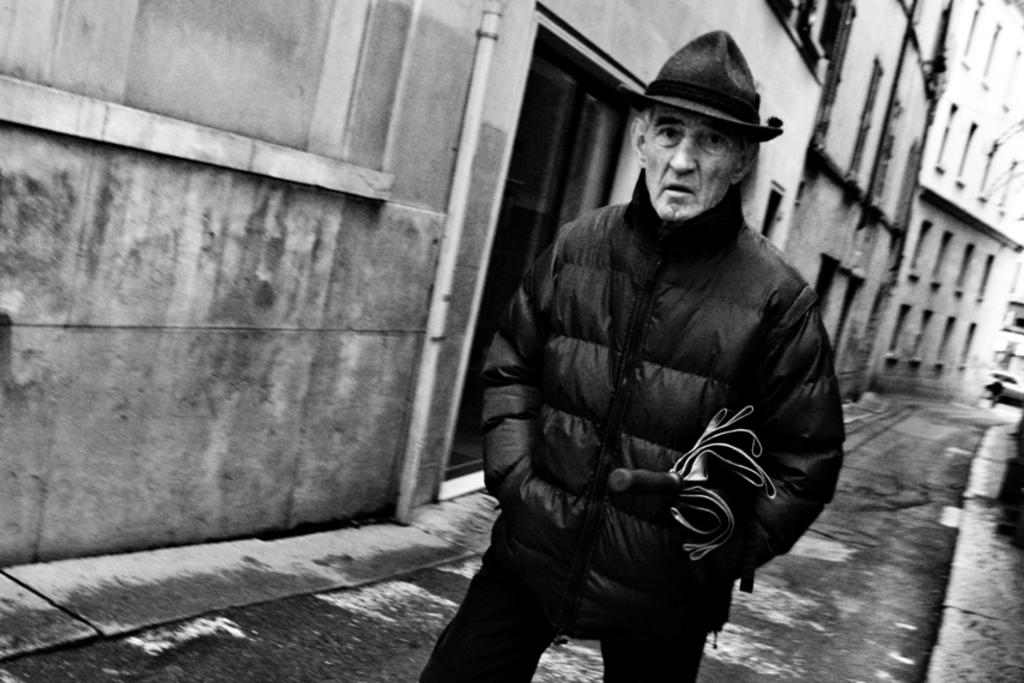What can be seen in the image? There is a person in the image. Can you describe the person's attire? The person is wearing a hat and a jacket. What object is the person holding? The person is holding an umbrella. What can be seen in the background of the image? There are buildings visible in the background of the image, on the left side. What type of rifle is the person using in the image? There is no rifle present in the image; the person is holding an umbrella. Can you describe the person's motion in the image? The image is a still photograph, so there is no motion depicted. 